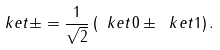Convert formula to latex. <formula><loc_0><loc_0><loc_500><loc_500>\ k e t { \pm } = \frac { 1 } { \sqrt { 2 } } \left ( \ k e t { 0 } \pm \ k e t { 1 } \right ) .</formula> 